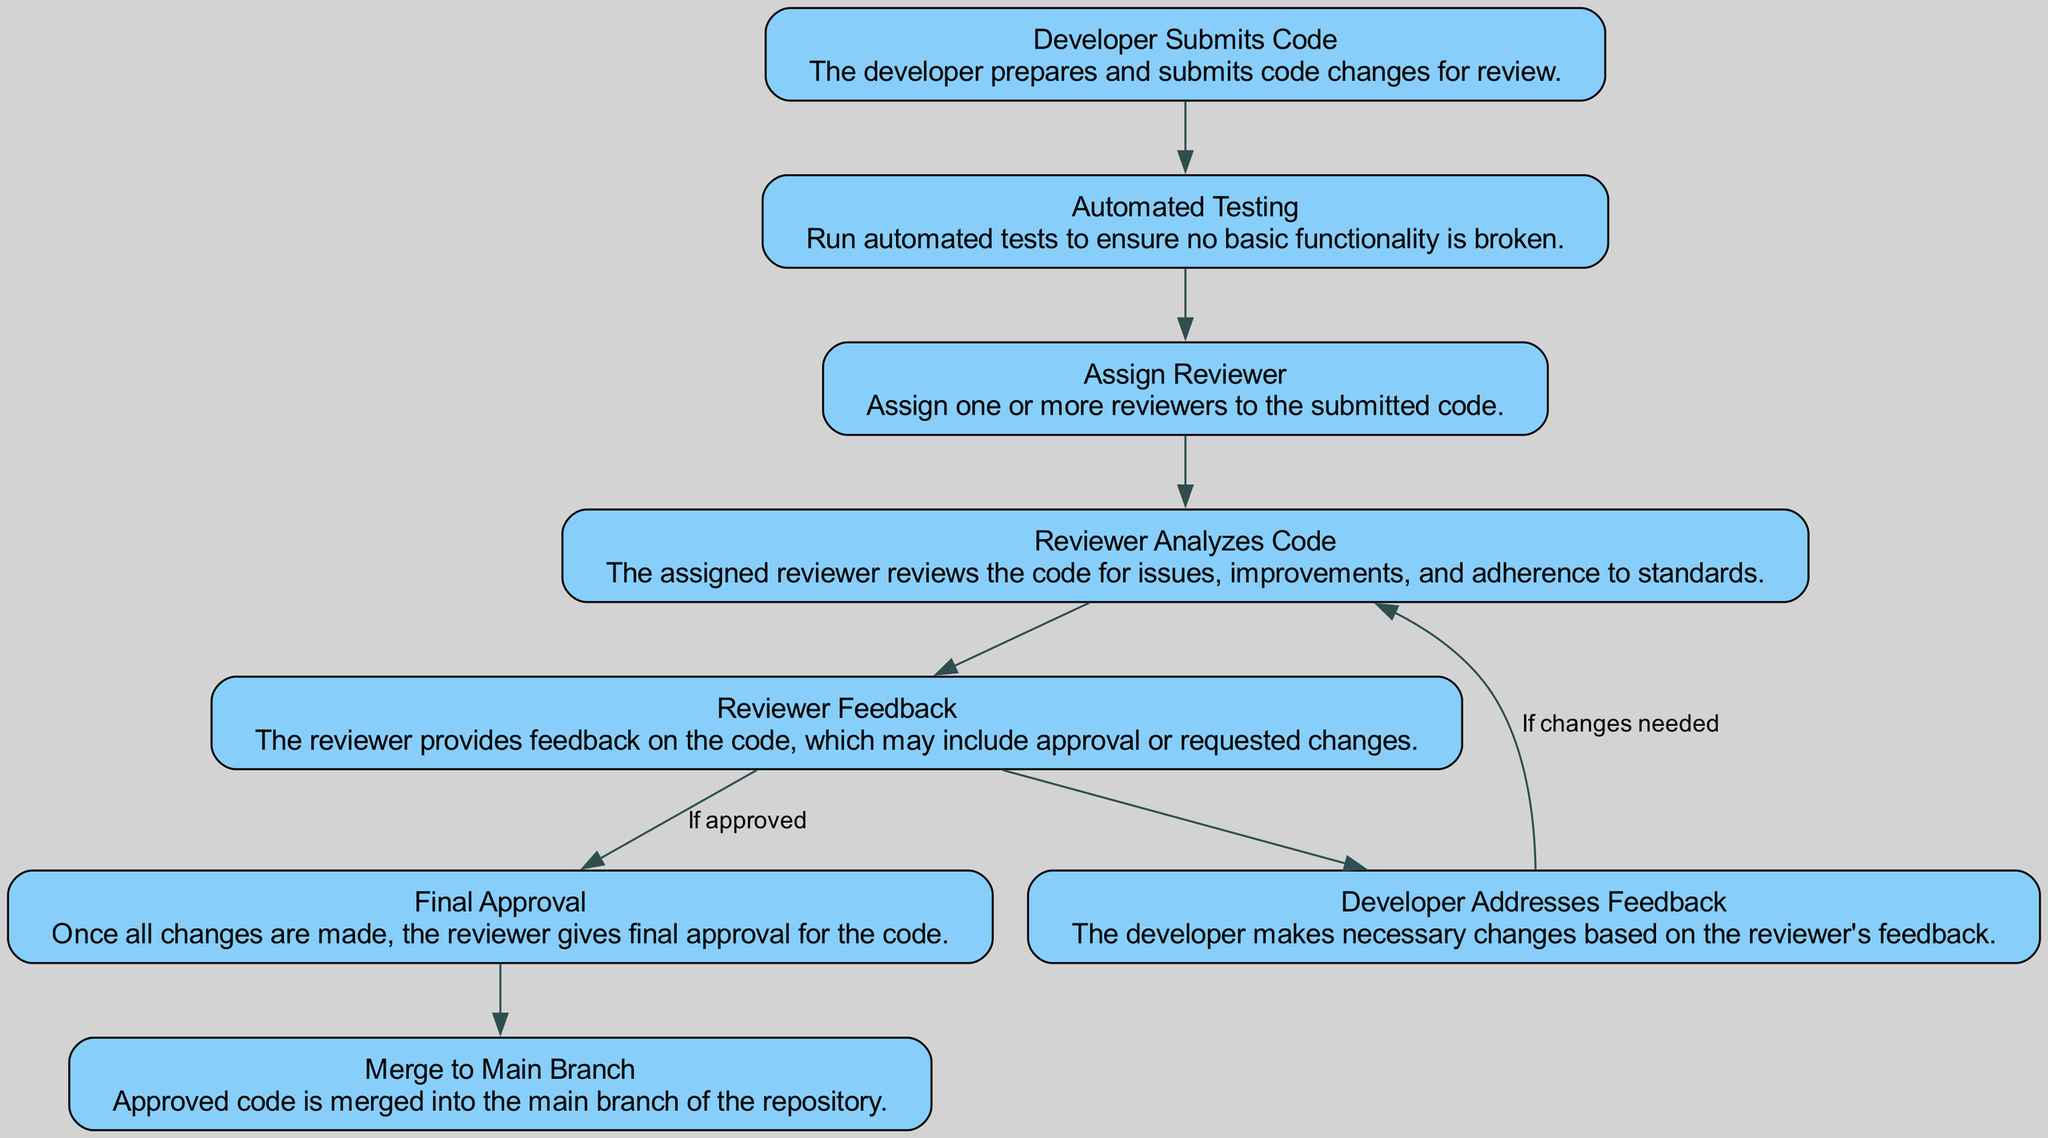What is the first step in the code review workflow? The first step is "Developer Submits Code," as it is the initial node in the diagram, indicating the beginning of the workflow process.
Answer: Developer Submits Code How many nodes are present in the diagram? By counting each unique step in the workflow represented as nodes, there are a total of eight nodes in the diagram.
Answer: Eight What comes after "Automated Testing" in the workflow? After "Automated Testing," the next step is "Assign Reviewer," which is the subsequent node in the diagram's flow.
Answer: Assign Reviewer What happens if the reviewer requires changes? If changes are needed, the workflow loops back to "Reviewer Analyzes Code," indicating that the developer must make adjustments before resubmission.
Answer: Reviewer Analyzes Code What is the final step after receiving "Final Approval"? The final step after "Final Approval" is to "Merge to Main Branch," completing the process of integrating the approved code into the main codebase.
Answer: Merge to Main Branch What action does the developer take after receiving "Reviewer Feedback"? After receiving "Reviewer Feedback," the developer "Addresses Feedback" to implement the requested changes or improvements from the reviewer.
Answer: Addresses Feedback What signifies the transition from "Reviewer Feedback" to "Final Approval"? The transition from "Reviewer Feedback" to "Final Approval" occurs if the code is "approved," indicating that the reviewer is satisfied with the changes made.
Answer: Approved How is "Automated Testing" linked to "Assign Reviewer"? "Automated Testing" is linked to "Assign Reviewer" as the flow moves linearly from one process to the next, indicating that the next step follows after completing automated tests.
Answer: Directly linked What happens after "Developer Addresses Feedback"? After "Developer Addresses Feedback," the workflow loops back to "Reviewer Analyzes Code," which means the reviewer needs to reassess the changes made by the developer.
Answer: Reviewer Analyzes Code 